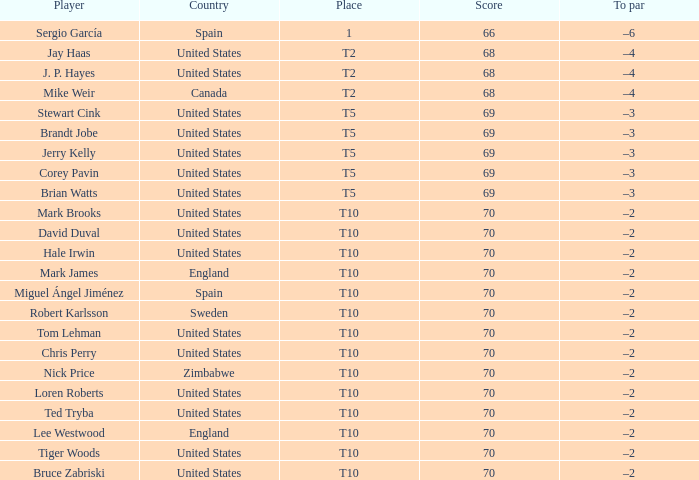What was the highest score of t5 place finisher brandt jobe? 69.0. 